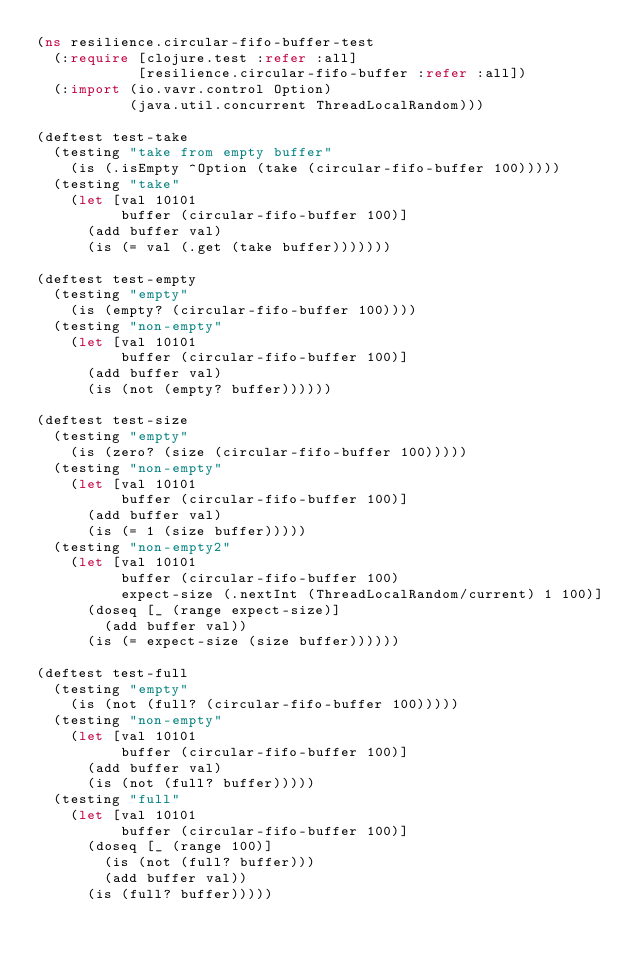Convert code to text. <code><loc_0><loc_0><loc_500><loc_500><_Clojure_>(ns resilience.circular-fifo-buffer-test
  (:require [clojure.test :refer :all]
            [resilience.circular-fifo-buffer :refer :all])
  (:import (io.vavr.control Option)
           (java.util.concurrent ThreadLocalRandom)))

(deftest test-take
  (testing "take from empty buffer"
    (is (.isEmpty ^Option (take (circular-fifo-buffer 100)))))
  (testing "take"
    (let [val 10101
          buffer (circular-fifo-buffer 100)]
      (add buffer val)
      (is (= val (.get (take buffer)))))))

(deftest test-empty
  (testing "empty"
    (is (empty? (circular-fifo-buffer 100))))
  (testing "non-empty"
    (let [val 10101
          buffer (circular-fifo-buffer 100)]
      (add buffer val)
      (is (not (empty? buffer))))))

(deftest test-size
  (testing "empty"
    (is (zero? (size (circular-fifo-buffer 100)))))
  (testing "non-empty"
    (let [val 10101
          buffer (circular-fifo-buffer 100)]
      (add buffer val)
      (is (= 1 (size buffer)))))
  (testing "non-empty2"
    (let [val 10101
          buffer (circular-fifo-buffer 100)
          expect-size (.nextInt (ThreadLocalRandom/current) 1 100)]
      (doseq [_ (range expect-size)]
        (add buffer val))
      (is (= expect-size (size buffer))))))

(deftest test-full
  (testing "empty"
    (is (not (full? (circular-fifo-buffer 100)))))
  (testing "non-empty"
    (let [val 10101
          buffer (circular-fifo-buffer 100)]
      (add buffer val)
      (is (not (full? buffer)))))
  (testing "full"
    (let [val 10101
          buffer (circular-fifo-buffer 100)]
      (doseq [_ (range 100)]
        (is (not (full? buffer)))
        (add buffer val))
      (is (full? buffer)))))
</code> 